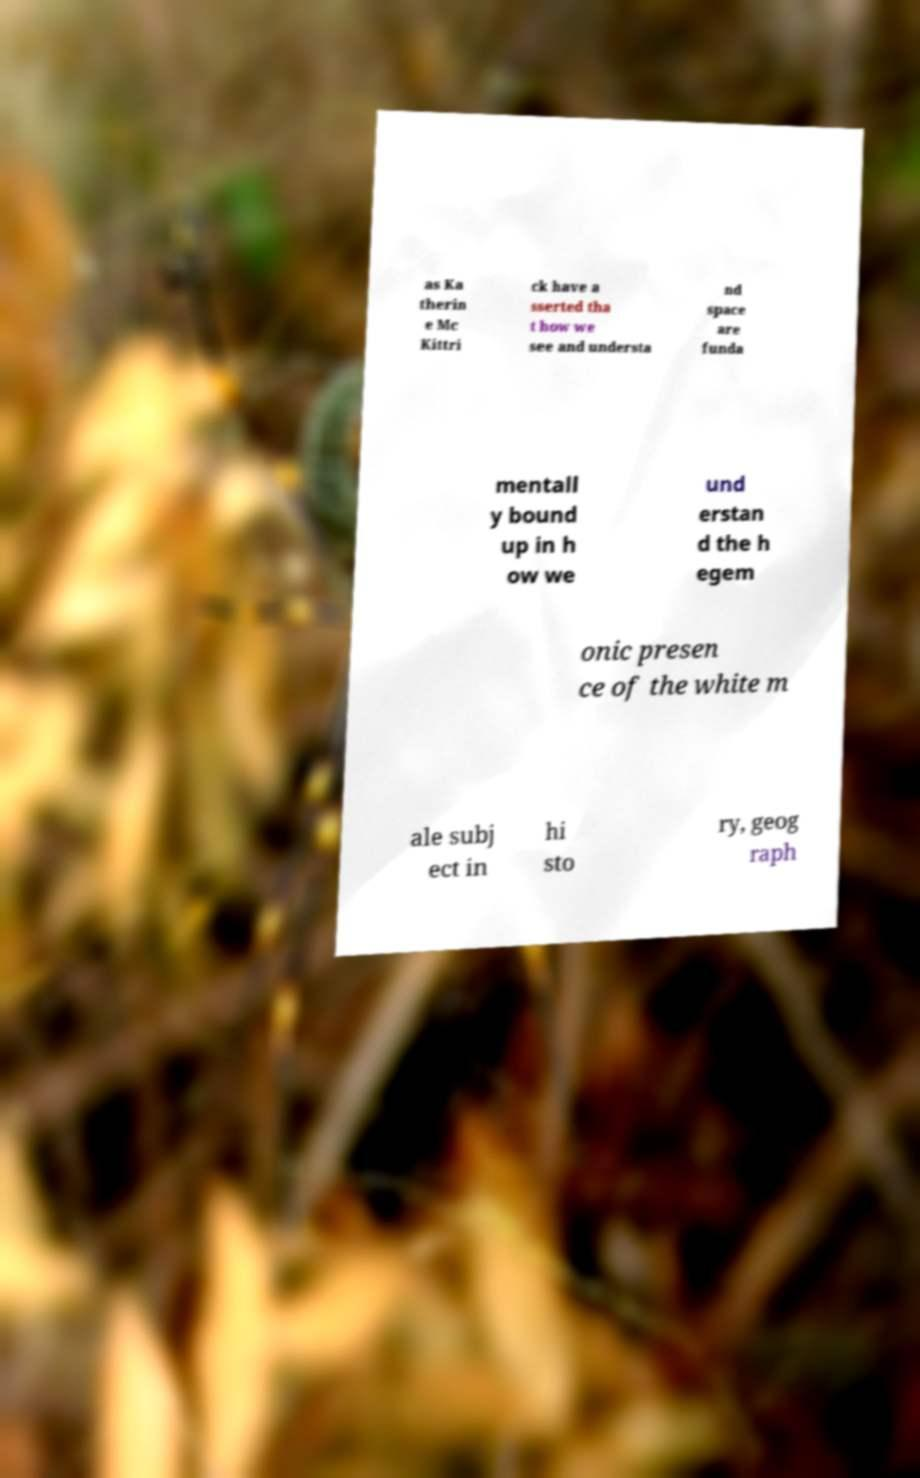Can you accurately transcribe the text from the provided image for me? as Ka therin e Mc Kittri ck have a sserted tha t how we see and understa nd space are funda mentall y bound up in h ow we und erstan d the h egem onic presen ce of the white m ale subj ect in hi sto ry, geog raph 